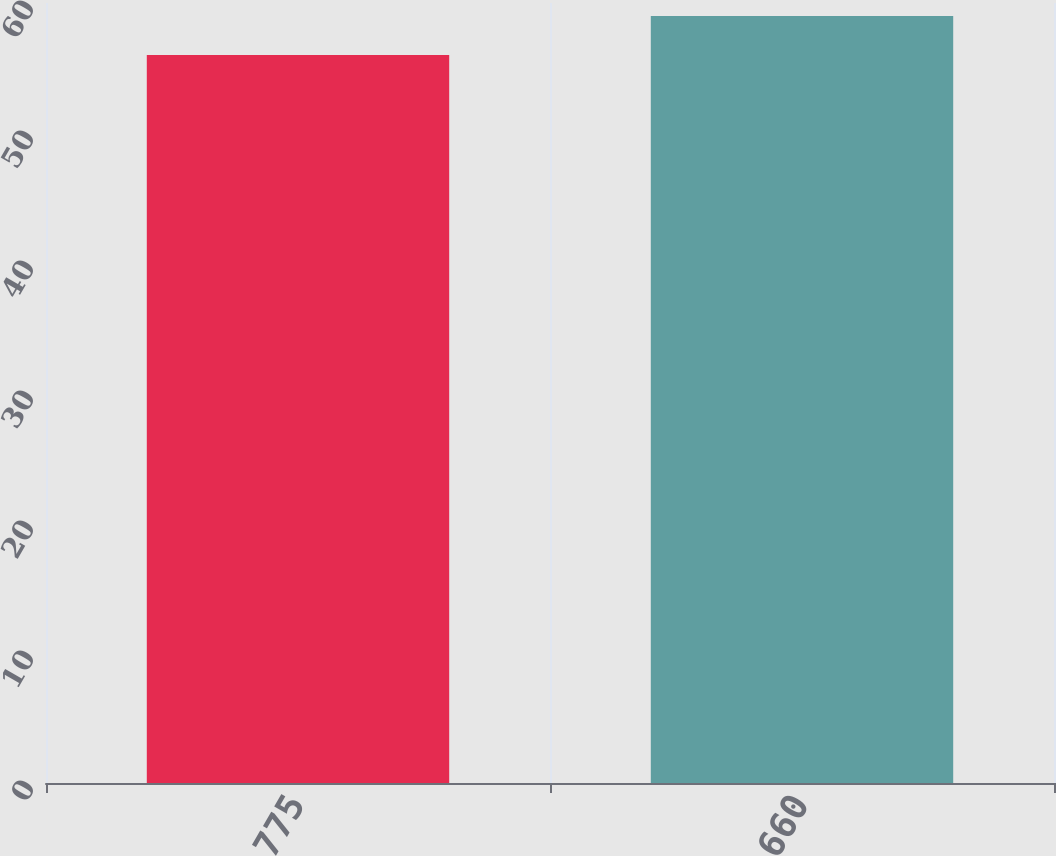Convert chart to OTSL. <chart><loc_0><loc_0><loc_500><loc_500><bar_chart><fcel>775<fcel>660<nl><fcel>56<fcel>59<nl></chart> 